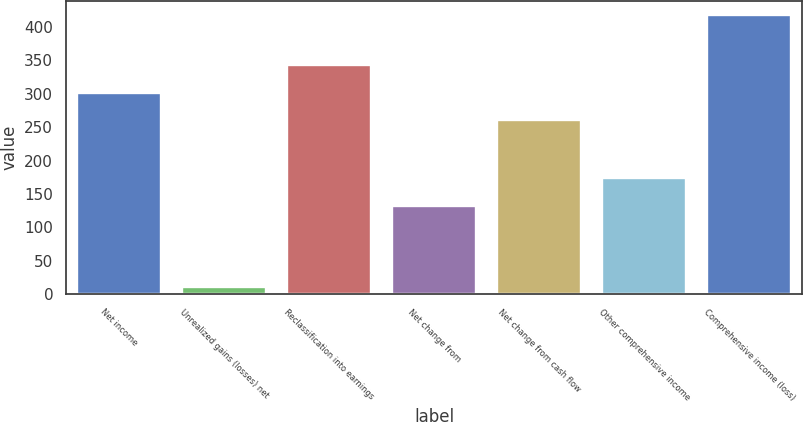Convert chart to OTSL. <chart><loc_0><loc_0><loc_500><loc_500><bar_chart><fcel>Net income<fcel>Unrealized gains (losses) net<fcel>Reclassification into earnings<fcel>Net change from<fcel>Net change from cash flow<fcel>Other comprehensive income<fcel>Comprehensive income (loss)<nl><fcel>301.8<fcel>10<fcel>342.6<fcel>132.4<fcel>261<fcel>173.2<fcel>418<nl></chart> 